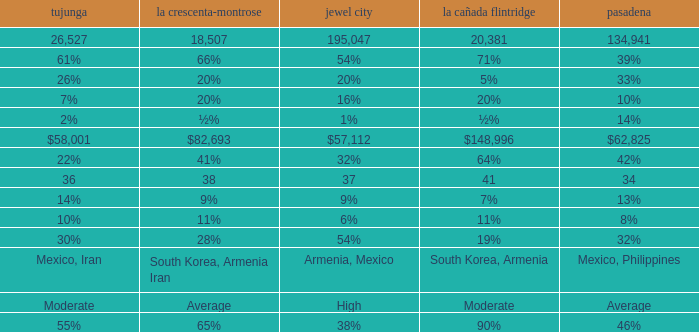What is the figure for La Crescenta-Montrose when Gelndale is $57,112? $82,693. 